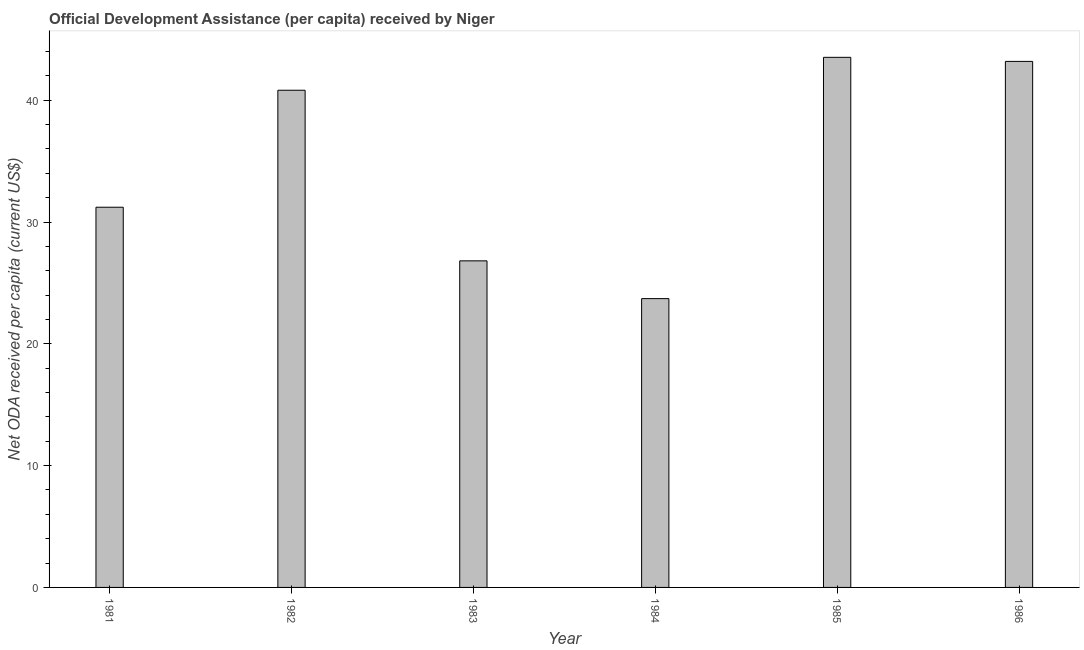What is the title of the graph?
Provide a short and direct response. Official Development Assistance (per capita) received by Niger. What is the label or title of the X-axis?
Offer a terse response. Year. What is the label or title of the Y-axis?
Your answer should be very brief. Net ODA received per capita (current US$). What is the net oda received per capita in 1986?
Your answer should be very brief. 43.19. Across all years, what is the maximum net oda received per capita?
Your response must be concise. 43.53. Across all years, what is the minimum net oda received per capita?
Your answer should be compact. 23.71. In which year was the net oda received per capita maximum?
Your response must be concise. 1985. In which year was the net oda received per capita minimum?
Give a very brief answer. 1984. What is the sum of the net oda received per capita?
Ensure brevity in your answer.  209.29. What is the difference between the net oda received per capita in 1982 and 1986?
Your answer should be very brief. -2.37. What is the average net oda received per capita per year?
Offer a very short reply. 34.88. What is the median net oda received per capita?
Your answer should be compact. 36.02. What is the ratio of the net oda received per capita in 1981 to that in 1982?
Your response must be concise. 0.77. Is the net oda received per capita in 1985 less than that in 1986?
Your response must be concise. No. Is the difference between the net oda received per capita in 1982 and 1983 greater than the difference between any two years?
Offer a very short reply. No. What is the difference between the highest and the second highest net oda received per capita?
Offer a terse response. 0.34. Is the sum of the net oda received per capita in 1981 and 1982 greater than the maximum net oda received per capita across all years?
Your response must be concise. Yes. What is the difference between the highest and the lowest net oda received per capita?
Your answer should be compact. 19.81. How many bars are there?
Your answer should be very brief. 6. Are the values on the major ticks of Y-axis written in scientific E-notation?
Offer a terse response. No. What is the Net ODA received per capita (current US$) of 1981?
Offer a very short reply. 31.22. What is the Net ODA received per capita (current US$) in 1982?
Your response must be concise. 40.82. What is the Net ODA received per capita (current US$) in 1983?
Offer a very short reply. 26.81. What is the Net ODA received per capita (current US$) of 1984?
Make the answer very short. 23.71. What is the Net ODA received per capita (current US$) of 1985?
Provide a short and direct response. 43.53. What is the Net ODA received per capita (current US$) of 1986?
Make the answer very short. 43.19. What is the difference between the Net ODA received per capita (current US$) in 1981 and 1982?
Give a very brief answer. -9.61. What is the difference between the Net ODA received per capita (current US$) in 1981 and 1983?
Offer a very short reply. 4.4. What is the difference between the Net ODA received per capita (current US$) in 1981 and 1984?
Make the answer very short. 7.5. What is the difference between the Net ODA received per capita (current US$) in 1981 and 1985?
Provide a succinct answer. -12.31. What is the difference between the Net ODA received per capita (current US$) in 1981 and 1986?
Make the answer very short. -11.97. What is the difference between the Net ODA received per capita (current US$) in 1982 and 1983?
Your answer should be very brief. 14.01. What is the difference between the Net ODA received per capita (current US$) in 1982 and 1984?
Your answer should be very brief. 17.11. What is the difference between the Net ODA received per capita (current US$) in 1982 and 1985?
Provide a short and direct response. -2.7. What is the difference between the Net ODA received per capita (current US$) in 1982 and 1986?
Keep it short and to the point. -2.37. What is the difference between the Net ODA received per capita (current US$) in 1983 and 1984?
Give a very brief answer. 3.1. What is the difference between the Net ODA received per capita (current US$) in 1983 and 1985?
Keep it short and to the point. -16.71. What is the difference between the Net ODA received per capita (current US$) in 1983 and 1986?
Make the answer very short. -16.38. What is the difference between the Net ODA received per capita (current US$) in 1984 and 1985?
Your response must be concise. -19.81. What is the difference between the Net ODA received per capita (current US$) in 1984 and 1986?
Offer a terse response. -19.48. What is the difference between the Net ODA received per capita (current US$) in 1985 and 1986?
Your answer should be very brief. 0.33. What is the ratio of the Net ODA received per capita (current US$) in 1981 to that in 1982?
Give a very brief answer. 0.77. What is the ratio of the Net ODA received per capita (current US$) in 1981 to that in 1983?
Your response must be concise. 1.16. What is the ratio of the Net ODA received per capita (current US$) in 1981 to that in 1984?
Provide a short and direct response. 1.32. What is the ratio of the Net ODA received per capita (current US$) in 1981 to that in 1985?
Ensure brevity in your answer.  0.72. What is the ratio of the Net ODA received per capita (current US$) in 1981 to that in 1986?
Offer a terse response. 0.72. What is the ratio of the Net ODA received per capita (current US$) in 1982 to that in 1983?
Ensure brevity in your answer.  1.52. What is the ratio of the Net ODA received per capita (current US$) in 1982 to that in 1984?
Keep it short and to the point. 1.72. What is the ratio of the Net ODA received per capita (current US$) in 1982 to that in 1985?
Your answer should be compact. 0.94. What is the ratio of the Net ODA received per capita (current US$) in 1982 to that in 1986?
Make the answer very short. 0.94. What is the ratio of the Net ODA received per capita (current US$) in 1983 to that in 1984?
Provide a succinct answer. 1.13. What is the ratio of the Net ODA received per capita (current US$) in 1983 to that in 1985?
Keep it short and to the point. 0.62. What is the ratio of the Net ODA received per capita (current US$) in 1983 to that in 1986?
Give a very brief answer. 0.62. What is the ratio of the Net ODA received per capita (current US$) in 1984 to that in 1985?
Your answer should be compact. 0.55. What is the ratio of the Net ODA received per capita (current US$) in 1984 to that in 1986?
Give a very brief answer. 0.55. What is the ratio of the Net ODA received per capita (current US$) in 1985 to that in 1986?
Your response must be concise. 1.01. 